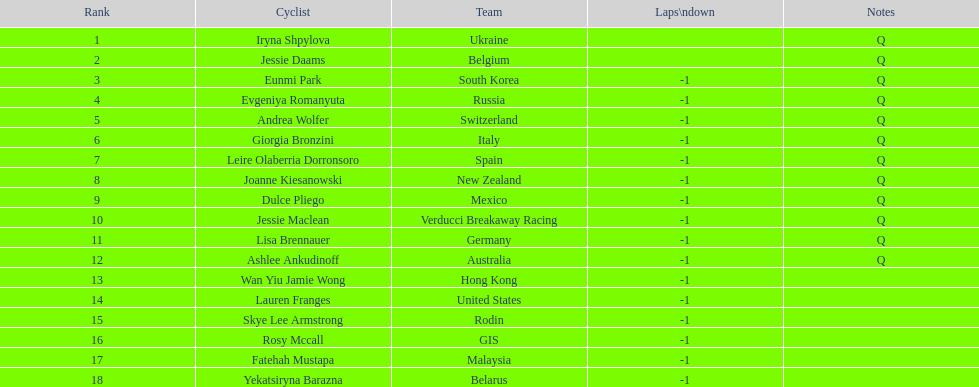Which team comes preceding belgium? Ukraine. Would you be able to parse every entry in this table? {'header': ['Rank', 'Cyclist', 'Team', 'Laps\\ndown', 'Notes'], 'rows': [['1', 'Iryna Shpylova', 'Ukraine', '', 'Q'], ['2', 'Jessie Daams', 'Belgium', '', 'Q'], ['3', 'Eunmi Park', 'South Korea', '-1', 'Q'], ['4', 'Evgeniya Romanyuta', 'Russia', '-1', 'Q'], ['5', 'Andrea Wolfer', 'Switzerland', '-1', 'Q'], ['6', 'Giorgia Bronzini', 'Italy', '-1', 'Q'], ['7', 'Leire Olaberria Dorronsoro', 'Spain', '-1', 'Q'], ['8', 'Joanne Kiesanowski', 'New Zealand', '-1', 'Q'], ['9', 'Dulce Pliego', 'Mexico', '-1', 'Q'], ['10', 'Jessie Maclean', 'Verducci Breakaway Racing', '-1', 'Q'], ['11', 'Lisa Brennauer', 'Germany', '-1', 'Q'], ['12', 'Ashlee Ankudinoff', 'Australia', '-1', 'Q'], ['13', 'Wan Yiu Jamie Wong', 'Hong Kong', '-1', ''], ['14', 'Lauren Franges', 'United States', '-1', ''], ['15', 'Skye Lee Armstrong', 'Rodin', '-1', ''], ['16', 'Rosy Mccall', 'GIS', '-1', ''], ['17', 'Fatehah Mustapa', 'Malaysia', '-1', ''], ['18', 'Yekatsiryna Barazna', 'Belarus', '-1', '']]} 